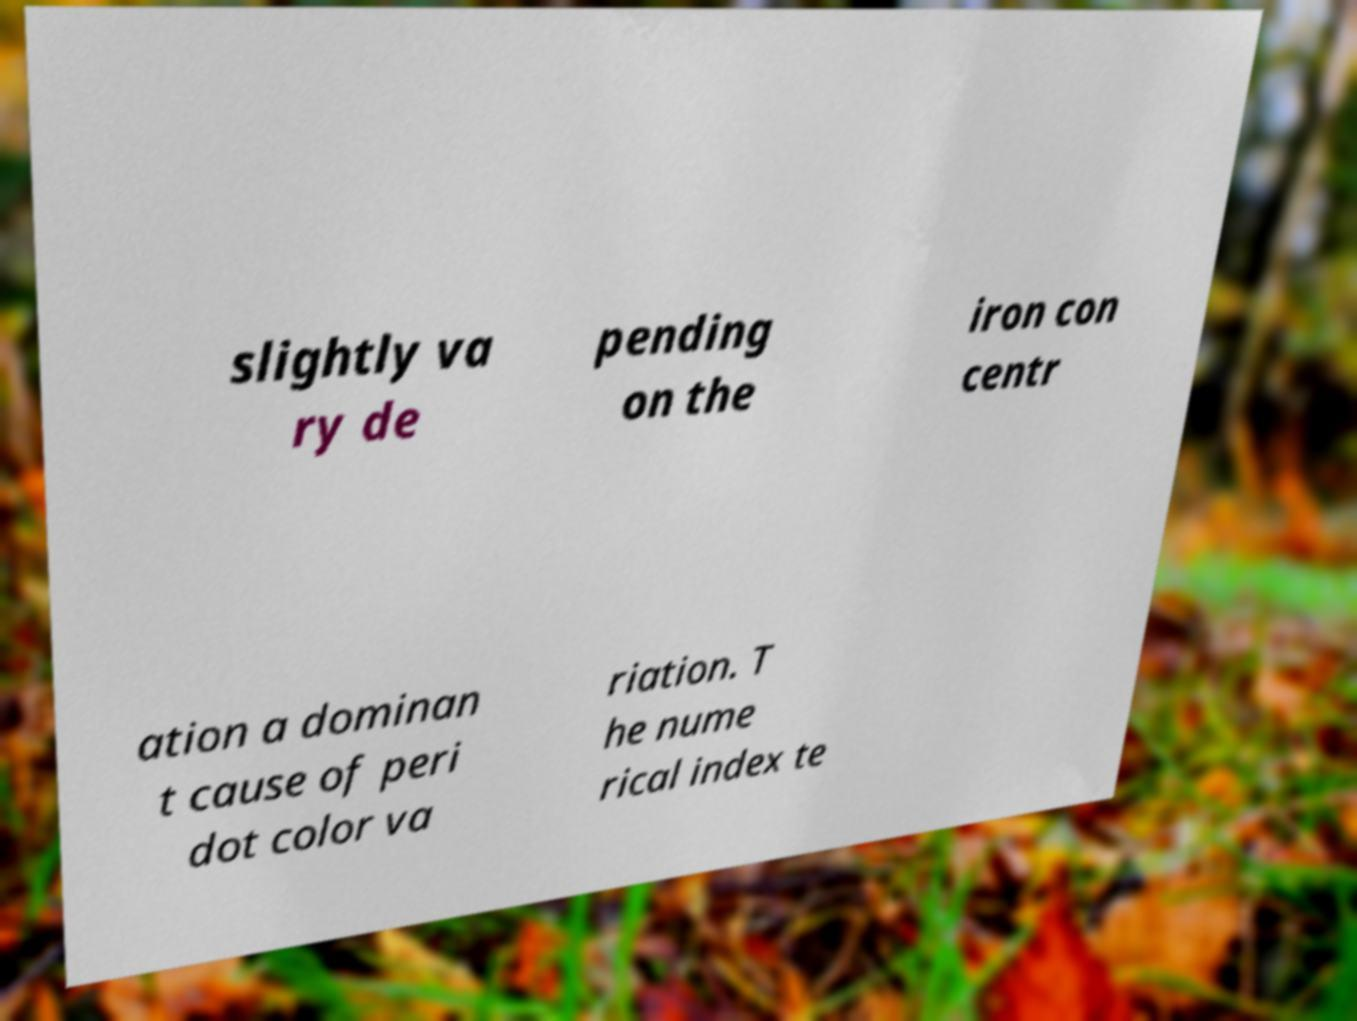Please identify and transcribe the text found in this image. slightly va ry de pending on the iron con centr ation a dominan t cause of peri dot color va riation. T he nume rical index te 